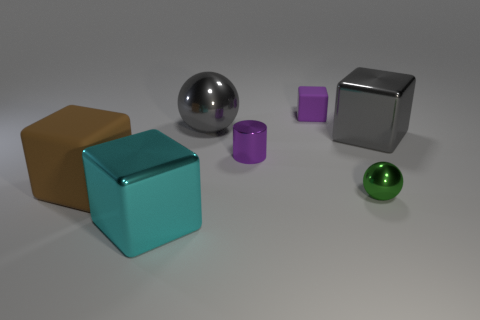Subtract all large cyan metallic cubes. How many cubes are left? 3 Subtract all gray blocks. How many blocks are left? 3 Add 1 tiny cyan matte balls. How many objects exist? 8 Subtract all cyan cubes. Subtract all yellow cylinders. How many cubes are left? 3 Subtract all cylinders. How many objects are left? 6 Subtract all green shiny things. Subtract all large gray metallic blocks. How many objects are left? 5 Add 1 brown objects. How many brown objects are left? 2 Add 7 brown rubber cubes. How many brown rubber cubes exist? 8 Subtract 0 yellow blocks. How many objects are left? 7 